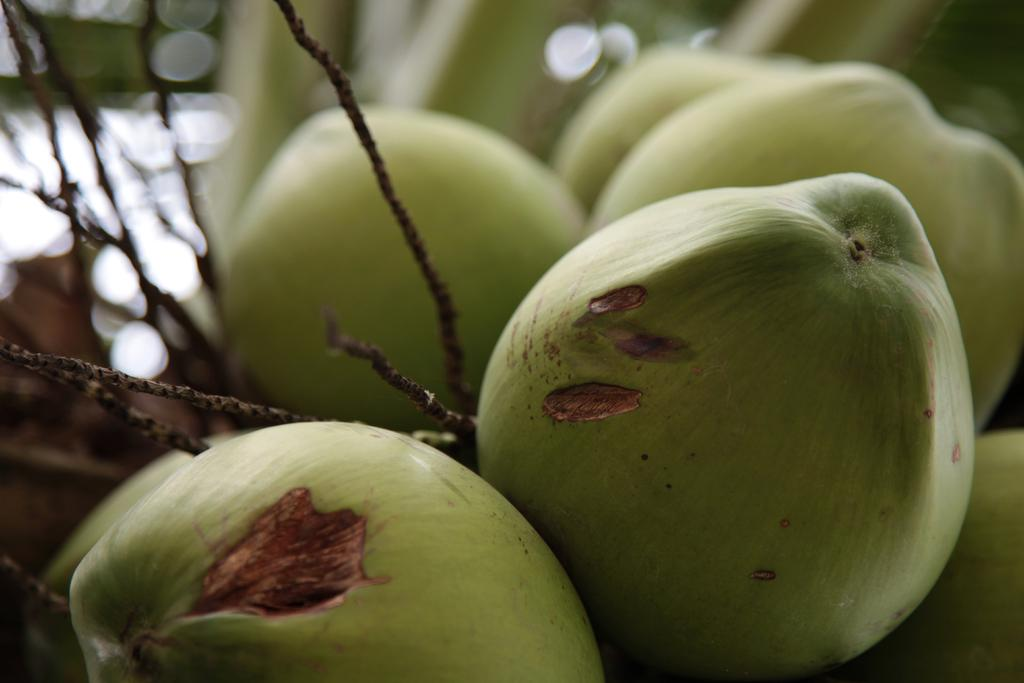What type of fruit is present in the image? There are coconuts in the image. Can you describe the background of the image? The background of the image is blurred. What type of dress is being worn by the industry in the image? There is no industry or dress present in the image; it only features coconuts and a blurred background. 